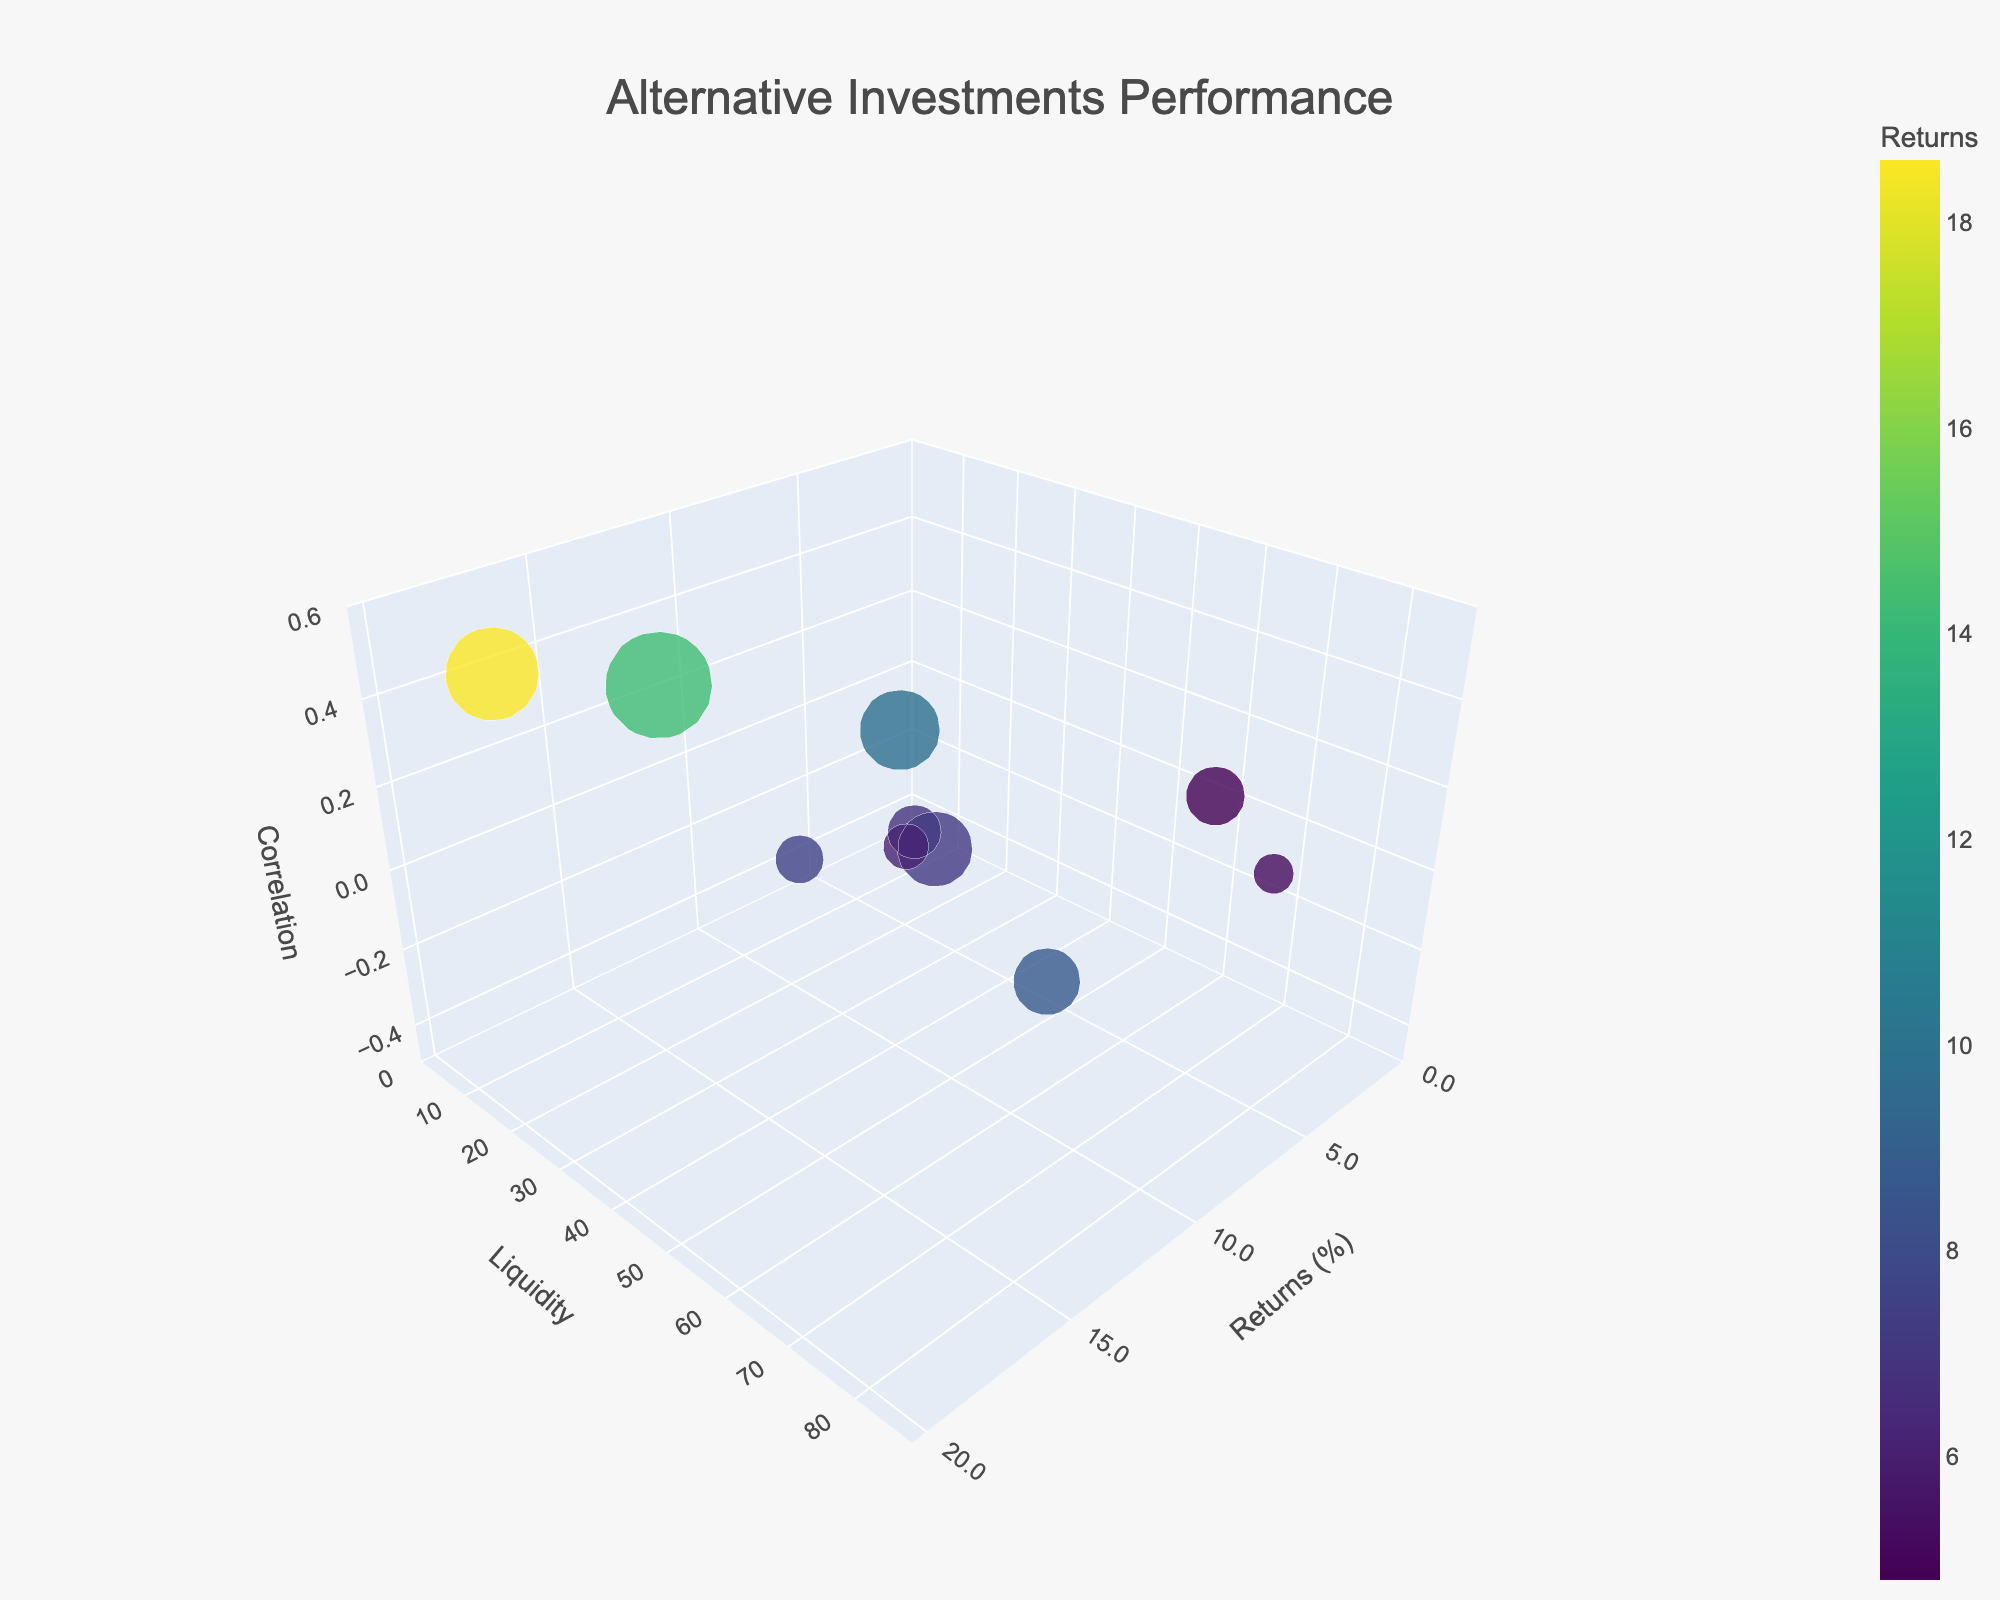What is the title of the figure? Look at the text centered at the top of the plot. The title is usually designed to summarize the essence of the figure.
Answer: Alternative Investments Performance Which investment has the highest return, and what is that return? Identify the point farthest along the returns axis (x-axis). The highest return value and associated investment name will be presented in the hover text or bubble position.
Answer: Venture Capital, 18.6% What is the liquidity of the investment with the highest return? Find the investment with the highest return (Venture Capital), then locate its corresponding liquidity value on the y-axis or hover text.
Answer: 15 Which investment has the lowest correlation with traditional markets? Look for the point farthest along the negative end of the correlation axis (z-axis). The lowest correlation value and associated investment name will be presented in the hover text or bubble position.
Answer: Fine Art, -0.3 How does the liquidity of Fine Art compare to the liquidity of Private Equity? Locate the points for Fine Art and Private Equity. Fine Art has a y-value of 10, and Private Equity has a y-value of 20. Compare these values directly by looking at the bubbles or hover text.
Answer: Fine Art has less liquidity than Private Equity Which two investments have similar returns but different correlations with traditional markets? Identify investments with close x-axis values but varied z-axis values by examining the bubble positions and hover texts. Example pairs include Hedge Funds (9.8% return, 0.3 correlation) and REITs (8.7% return, -0.2 correlation).
Answer: Hedge Funds and REITs What is the relationship between the return and liquidity of Gold? Locate the bubble for Gold and note its x and y values from the plot or hover text. Gold has a return (x-axis) of 5.2% and liquidity (y-axis) of 80. This indicates an investment with low return but high liquidity.
Answer: Low return, high liquidity Does higher liquidity generally correlate with higher returns among these investments? Observe the trends between x (Returns) and y (Liquidity) positions of all bubbles. Compare many higher return points with their corresponding liquidity values. If high return points tend to align with lower liquidity, this indicates an inverse relationship.
Answer: No, it does not Which investment has the largest bubble size, and what does this size represent? Identify the largest bubble to determine the corresponding investment and refer to the hover text for its size value. The size variable, scaled by multiplying by 1.5, represents the given attribute: Investment: Private Equity, Size: 40, hence scaled size = 40 * 1.5 = 60.
Answer: Private Equity, the scaled size is 60 